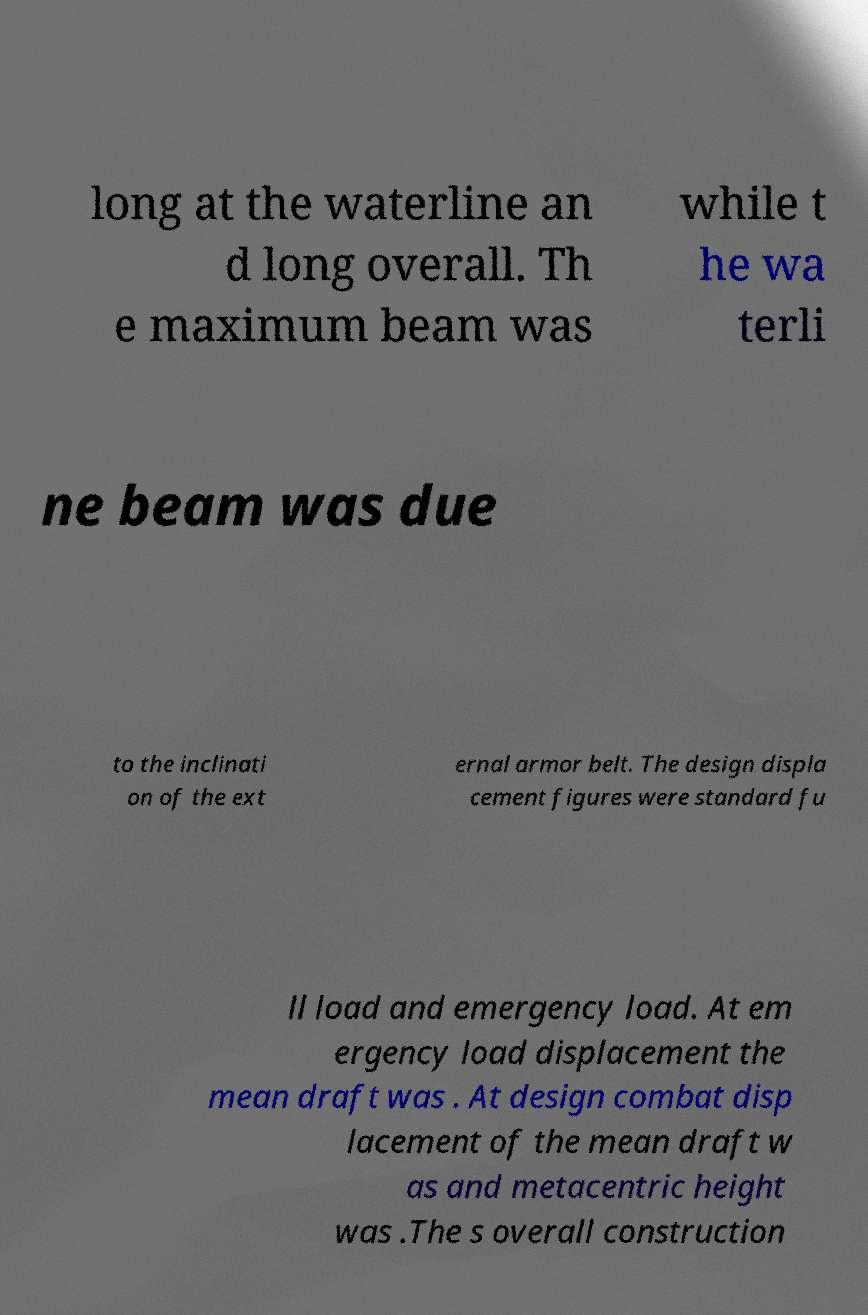What messages or text are displayed in this image? I need them in a readable, typed format. long at the waterline an d long overall. Th e maximum beam was while t he wa terli ne beam was due to the inclinati on of the ext ernal armor belt. The design displa cement figures were standard fu ll load and emergency load. At em ergency load displacement the mean draft was . At design combat disp lacement of the mean draft w as and metacentric height was .The s overall construction 